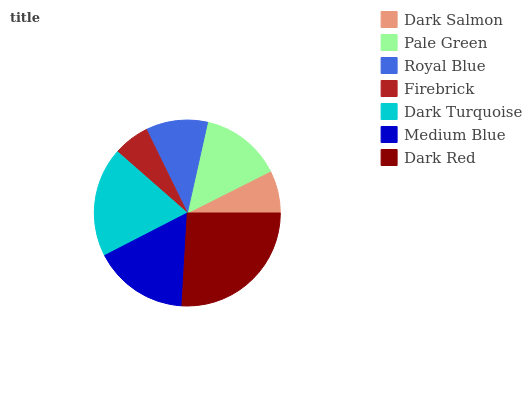Is Firebrick the minimum?
Answer yes or no. Yes. Is Dark Red the maximum?
Answer yes or no. Yes. Is Pale Green the minimum?
Answer yes or no. No. Is Pale Green the maximum?
Answer yes or no. No. Is Pale Green greater than Dark Salmon?
Answer yes or no. Yes. Is Dark Salmon less than Pale Green?
Answer yes or no. Yes. Is Dark Salmon greater than Pale Green?
Answer yes or no. No. Is Pale Green less than Dark Salmon?
Answer yes or no. No. Is Pale Green the high median?
Answer yes or no. Yes. Is Pale Green the low median?
Answer yes or no. Yes. Is Medium Blue the high median?
Answer yes or no. No. Is Dark Turquoise the low median?
Answer yes or no. No. 